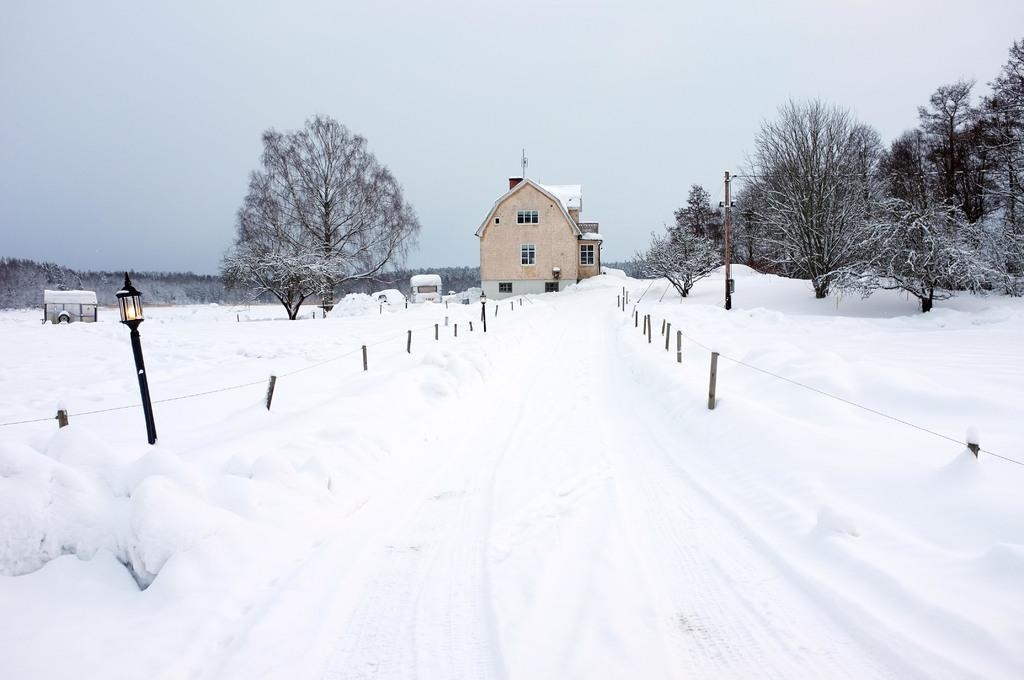What type of structure is visible in the image? There is a house with walls and windows in the image. What else can be seen in the image besides the house? There is a vehicle, trees, a shed, snow, a pole with a light, and rods visible in the image. What is the weather like in the image? There is snow in the image, indicating a cold or wintry weather condition. What is visible in the background of the image? The sky is visible in the background of the image. What type of glove is the brother wearing while working at the plantation in the image? There is no glove, brother, or plantation present in the image. 